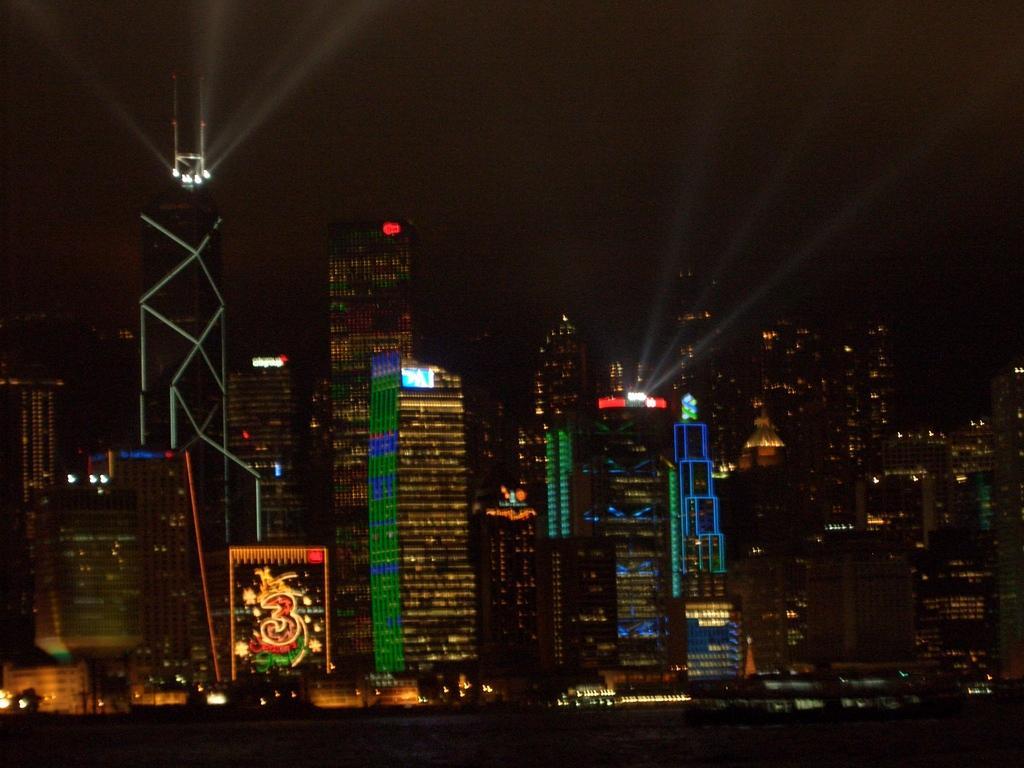Can you describe this image briefly? In this image in the background there are buildings and there are lights on the buildings and there is a number which is visible. 